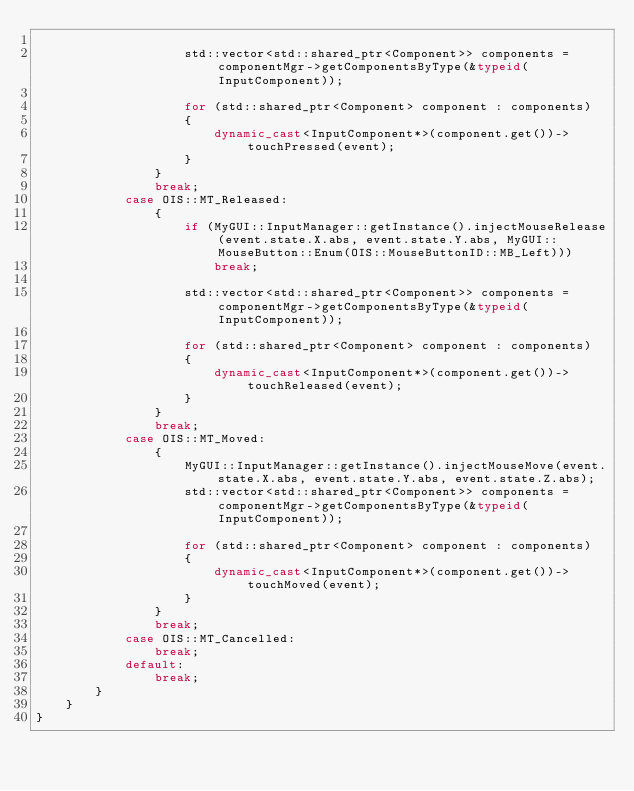<code> <loc_0><loc_0><loc_500><loc_500><_C++_>
					std::vector<std::shared_ptr<Component>> components = componentMgr->getComponentsByType(&typeid(InputComponent));

					for (std::shared_ptr<Component> component : components)
					{
						dynamic_cast<InputComponent*>(component.get())->touchPressed(event);
					}
				}
            	break;
            case OIS::MT_Released:
                {
					if (MyGUI::InputManager::getInstance().injectMouseRelease(event.state.X.abs, event.state.Y.abs, MyGUI::MouseButton::Enum(OIS::MouseButtonID::MB_Left)))
						break;

                	std::vector<std::shared_ptr<Component>> components = componentMgr->getComponentsByType(&typeid(InputComponent));

                	for (std::shared_ptr<Component> component : components)
                	{
                		dynamic_cast<InputComponent*>(component.get())->touchReleased(event);
                	}
				}
                break;
            case OIS::MT_Moved:
                {
                	MyGUI::InputManager::getInstance().injectMouseMove(event.state.X.abs, event.state.Y.abs, event.state.Z.abs);
					std::vector<std::shared_ptr<Component>> components = componentMgr->getComponentsByType(&typeid(InputComponent));

					for (std::shared_ptr<Component> component : components)
					{
						dynamic_cast<InputComponent*>(component.get())->touchMoved(event);
					}
				}
                break;
            case OIS::MT_Cancelled:
                break;
            default:
                break;
        }
    }
}
</code> 